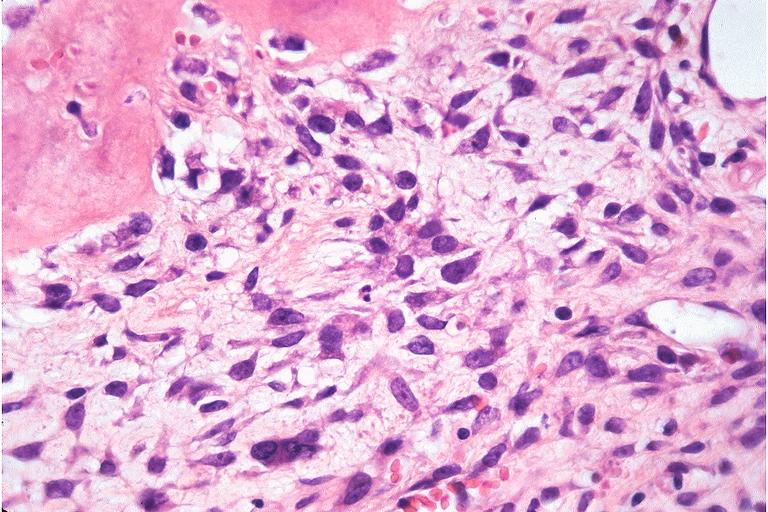what does this image show?
Answer the question using a single word or phrase. Osteosarcoma 